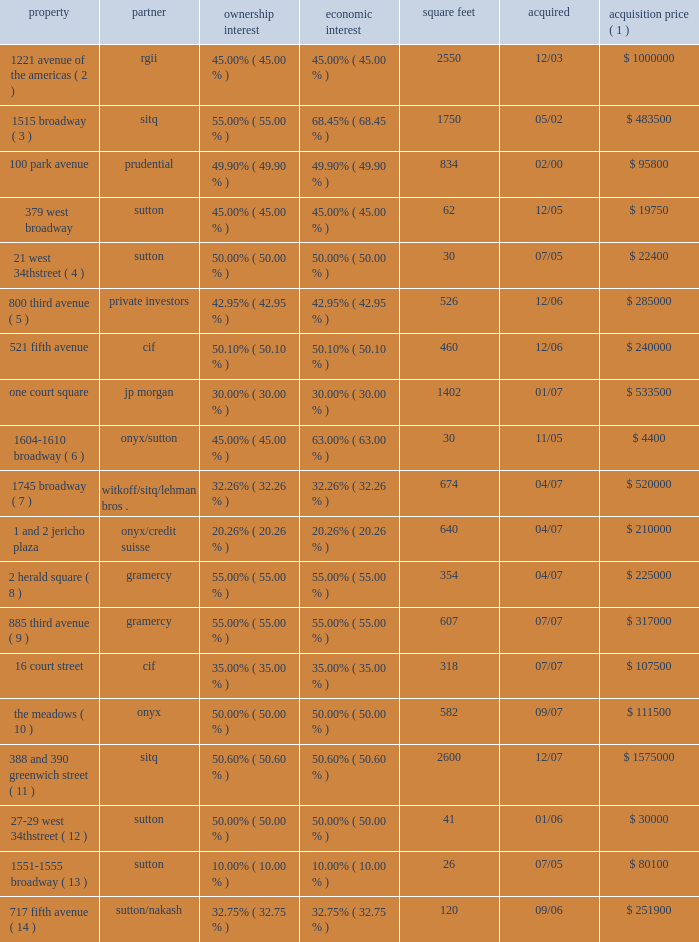Notes to consolidated financial statements minority partner approves the annual budget , receives a detailed monthly reporting package from us , meets with us on a quarterly basis to review the results of the joint venture , reviews and approves the joint venture 2019s tax return before filing , and approves all leases that cover more than a nominal amount of space relative to the total rentable space at each property we do not consolidate the joint venture as we consider these to be substantive participation rights .
Our joint venture agreements also contain certain pro- tective rights such as the requirement of partner approval to sell , finance or refinance the property and the payment of capital expenditures and operating expenditures outside of the approved budget or operating plan .
The table below provides general information on each joint venture as of december 31 , 2009 ( in thousands ) : property partner ownership interest economic interest square feet acquired acquisition price ( 1 ) 1221 avenue of the americas ( 2 ) rgii 45.00% ( 45.00 % ) 45.00% ( 45.00 % ) 2550 12/03 $ 1000000 1515 broadway ( 3 ) sitq 55.00% ( 55.00 % ) 68.45% ( 68.45 % ) 1750 05/02 $ 483500 .
The meadows ( 10 ) onyx 50.00% ( 50.00 % ) 50.00% ( 50.00 % ) 582 09/07 $ 111500 388 and 390 greenwich street ( 11 ) sitq 50.60% ( 50.60 % ) 50.60% ( 50.60 % ) 2600 12/07 $ 1575000 27 201329 west 34th street ( 12 ) sutton 50.00% ( 50.00 % ) 50.00% ( 50.00 % ) 41 01/06 $ 30000 1551 20131555 broadway ( 13 ) sutton 10.00% ( 10.00 % ) 10.00% ( 10.00 % ) 26 07/05 $ 80100 717 fifth avenue ( 14 ) sutton/nakash 32.75% ( 32.75 % ) 32.75% ( 32.75 % ) 120 09/06 $ 251900 ( 1 ) acquisition price represents the actual or implied purchase price for the joint venture .
( 2 ) we acquired our interest from the mcgraw-hill companies , or mhc .
Mhc is a tenant at the property and accounted for approximately 14.7% ( 14.7 % ) of the property 2019s annualized rent at december 31 , 2009 .
We do not manage this joint venture .
( 3 ) under a tax protection agreement established to protect the limited partners of the partnership that transferred 1515 broadway to the joint venture , the joint venture has agreed not to adversely affect the limited partners 2019 tax positions before december 2011 .
One tenant , whose leases primarily ends in 2015 , represents approximately 77.4% ( 77.4 % ) of this joint venture 2019s annualized rent at december 31 , 2009 .
( 4 ) effective november 2006 , we deconsolidated this investment .
As a result of the recapitalization of the property , we were no longer the primary beneficiary .
Both partners had the same amount of equity at risk and neither partner controlled the joint venture .
( 5 ) we invested approximately $ 109.5 million in this asset through the origination of a loan secured by up to 47% ( 47 % ) of the interests in the property 2019s ownership , with an option to convert the loan to an equity interest .
Certain existing members have the right to re-acquire approximately 4% ( 4 % ) of the property 2019s equity .
These interests were re-acquired in december 2008 and reduced our interest to 42.95% ( 42.95 % ) ( 6 ) effective april 2007 , we deconsolidated this investment .
As a result of the recapitalization of the property , we were no longer the primary beneficiary .
Both partners had the same amount of equity at risk and neither partner controlled the joint venture .
( 7 ) we have the ability to syndicate our interest down to 14.79% ( 14.79 % ) .
( 8 ) we , along with gramercy , together as tenants-in-common , acquired a fee interest in 2 herald square .
The fee interest is subject to a long-term operating lease .
( 9 ) we , along with gramercy , together as tenants-in-common , acquired a fee and leasehold interest in 885 third avenue .
The fee and leasehold interests are subject to a long-term operating lease .
( 10 ) we , along with onyx acquired the remaining 50% ( 50 % ) interest on a pro-rata basis in september 2009 .
( 11 ) the property is subject to a 13-year triple-net lease arrangement with a single tenant .
( 12 ) effective may 2008 , we deconsolidated this investment .
As a result of the recapitalization of the property , we were no longer the primary beneficiary .
Both partners had the same amount of equity at risk and neither partner controlled the joint venture .
( 13 ) effective august 2008 , we deconsolidated this investment .
As a result of the sale of 80% ( 80 % ) of our interest , the joint venture was no longer a vie .
( 14 ) effective september 2008 , we deconsolidated this investment .
As a result of the recapitalization of the property , we were no longer the primary beneficiary. .
What was the total value of the 100 park avenue property based in the acquisition price? 
Computations: ((95800 * 1000) / 49.90%)
Answer: 191983967.93587. 